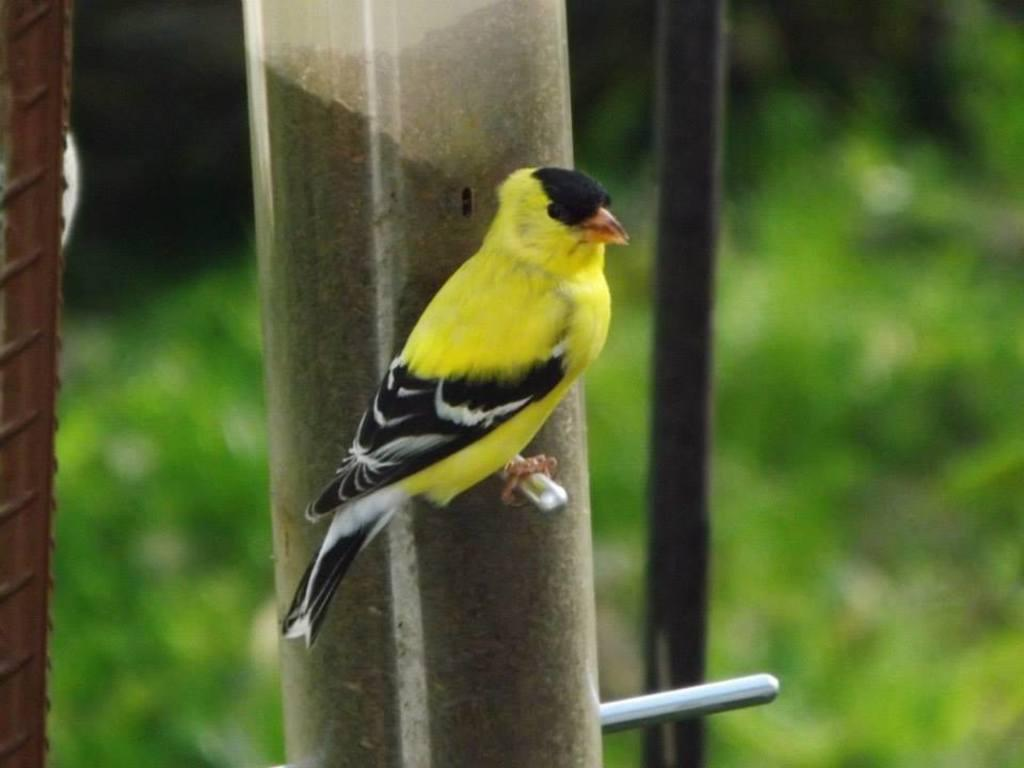What type of bird is in the image? There is a yellow and black color bird in the image. Where is the bird sitting? The bird is sitting on a steel bar. What is the steel bar attached to? The steel bar is attached to a pole. Can you describe the background of the image? There is another pole in the background of the image, which is green in color and blurred. Can you tell me the name of the watch the bird is wearing in the image? There is no watch present in the image, as the bird is a living creature and does not wear accessories like watches. 